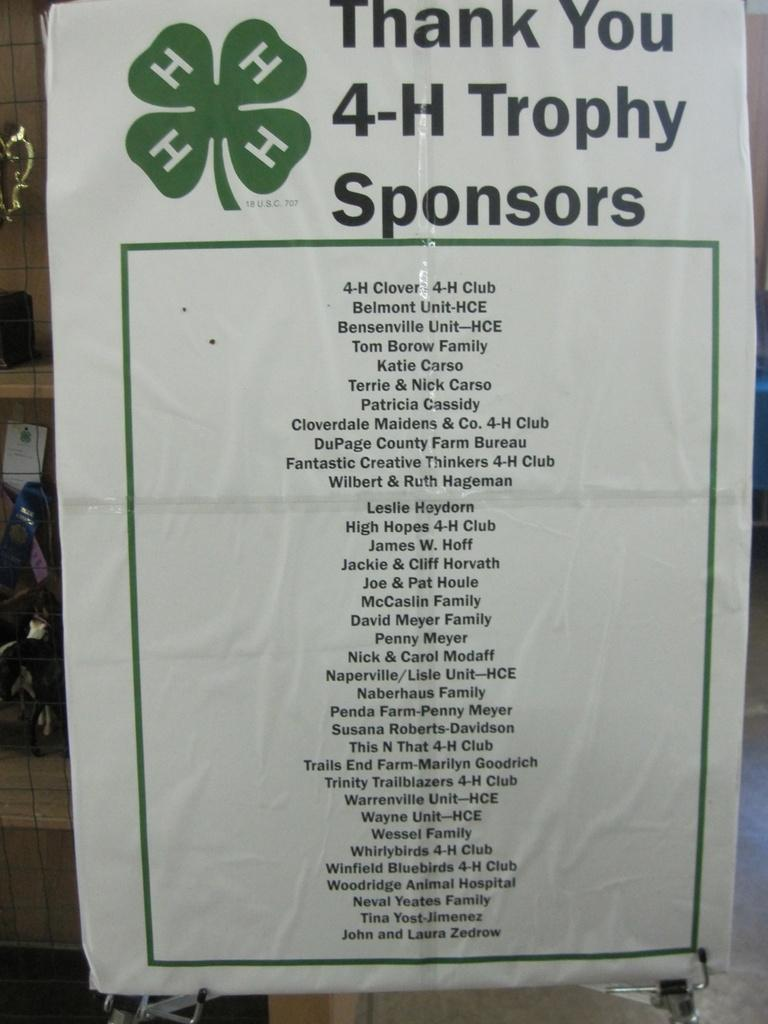Provide a one-sentence caption for the provided image. A poster thanking a list of trophy sponsors. 